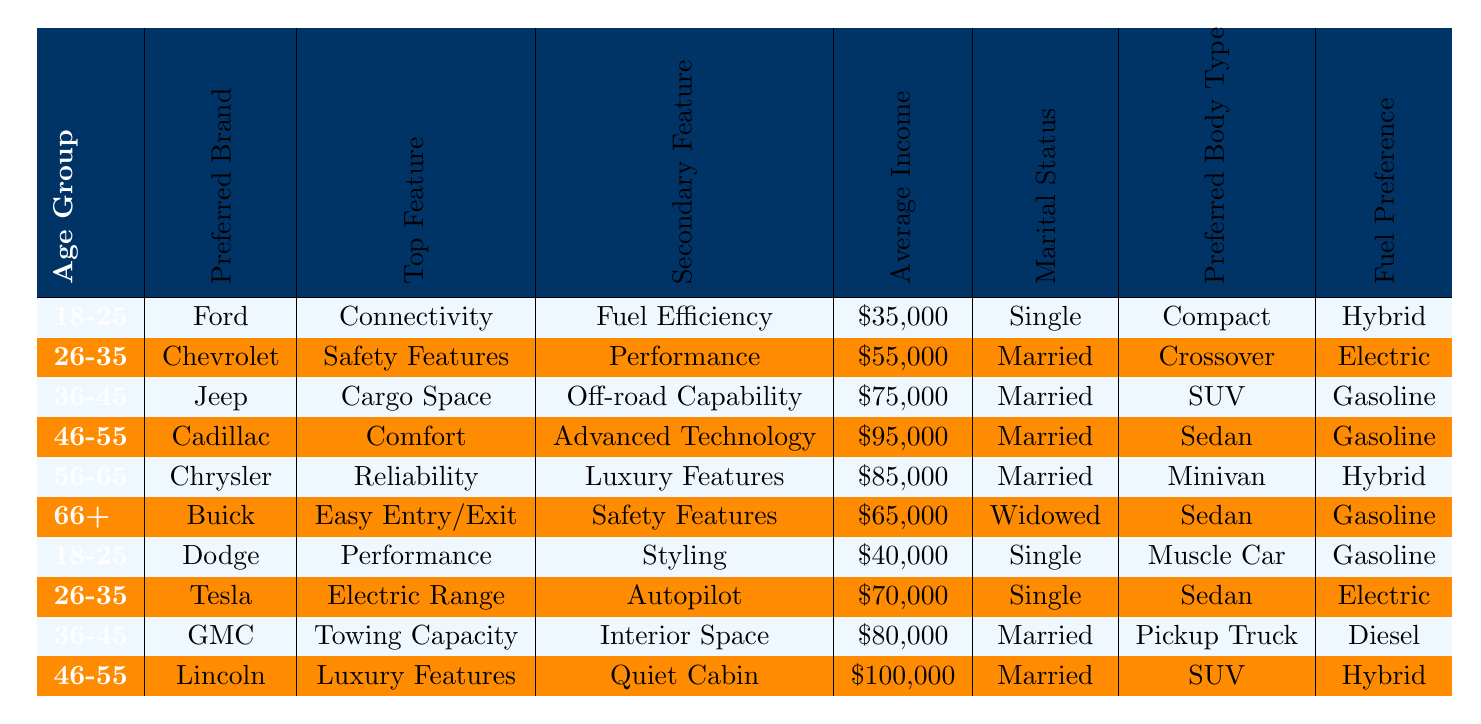What is the top feature preferred by the 36-45 age group? The 36-45 age group prefers Jeep, and their top feature is Cargo Space according to the table.
Answer: Cargo Space Which age group has the highest average income? The average incomes for the age groups are: 18-25: $37,500, 26-35: $62,500, 36-45: $77,500, 46-55: $97,500, 56-65: $82,500, and 66+: $65,000. The highest is for the 46-55 age group.
Answer: 46-55 Does the 56-65 age group prefer gasoline or hybrid fuel? The 56-65 age group prefers Hybrid fuel, as indicated in the table.
Answer: Hybrid Which marital status is most common for the 26-35 age group? The marital status for the 26-35 age group is married, according to the table.
Answer: Married What is the secondary feature preferred by the Cadillac owners aged 46-55? For Cadillac owners in the 46-55 age group, the secondary feature preferred is Advanced Technology.
Answer: Advanced Technology Are there any age groups that prefer compact body types? Yes, the 18-25 age group prefers Compact body types, as shown in the table.
Answer: Yes What body type do Jeep owners aged 36-45 prefer? The 36-45 age group who own a Jeep prefer an SUV body type.
Answer: SUV How many preferred body types are represented in the table? The preferred body types listed are Compact, Crossover, SUV, Sedan, Minivan, Muscle Car, and Pickup Truck, totaling seven unique types.
Answer: Seven Which fuel preference is common among those aged 66 and older? The table indicates that Buick owners aged 66+ have a fuel preference for Gasoline.
Answer: Gasoline Which age group prefers electric as their fuel preference? The 26-35 age group prefers Electric fuel, as shown for both Chevrolet and Tesla brands.
Answer: 26-35 